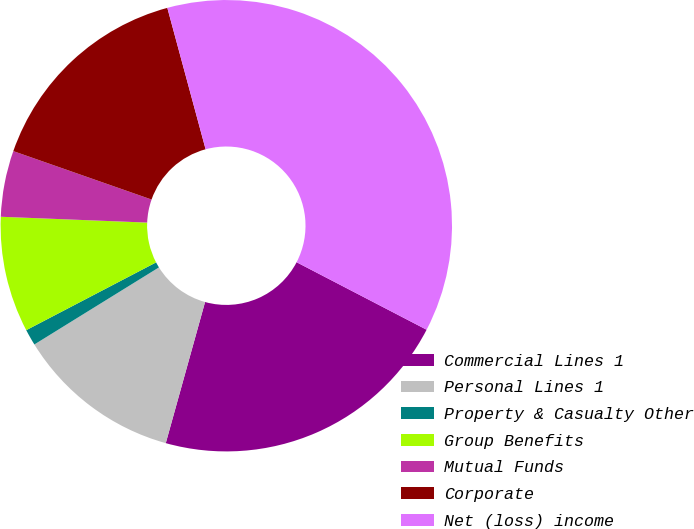<chart> <loc_0><loc_0><loc_500><loc_500><pie_chart><fcel>Commercial Lines 1<fcel>Personal Lines 1<fcel>Property & Casualty Other<fcel>Group Benefits<fcel>Mutual Funds<fcel>Corporate<fcel>Net (loss) income<nl><fcel>21.7%<fcel>11.86%<fcel>1.16%<fcel>8.29%<fcel>4.73%<fcel>15.43%<fcel>36.83%<nl></chart> 